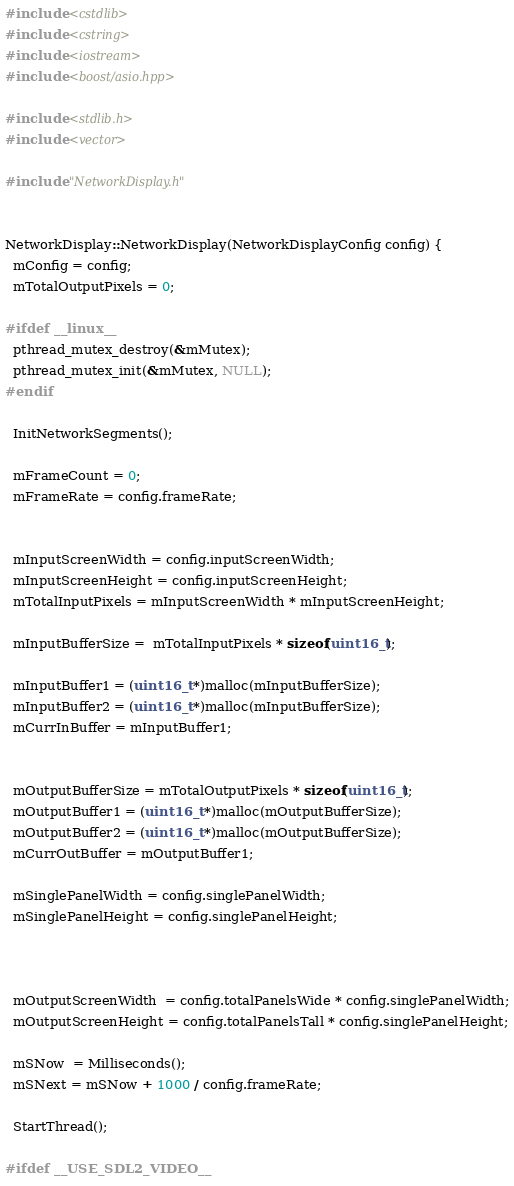<code> <loc_0><loc_0><loc_500><loc_500><_C++_>#include <cstdlib>
#include <cstring>
#include <iostream>
#include <boost/asio.hpp>

#include <stdlib.h>
#include <vector>

#include "NetworkDisplay.h"


NetworkDisplay::NetworkDisplay(NetworkDisplayConfig config) {
  mConfig = config;
  mTotalOutputPixels = 0;

#ifdef __linux__
  pthread_mutex_destroy(&mMutex);
  pthread_mutex_init(&mMutex, NULL);
#endif

  InitNetworkSegments();

  mFrameCount = 0;
  mFrameRate = config.frameRate;


  mInputScreenWidth = config.inputScreenWidth;
  mInputScreenHeight = config.inputScreenHeight;
  mTotalInputPixels = mInputScreenWidth * mInputScreenHeight;

  mInputBufferSize =  mTotalInputPixels * sizeof(uint16_t);

  mInputBuffer1 = (uint16_t *)malloc(mInputBufferSize);
  mInputBuffer2 = (uint16_t *)malloc(mInputBufferSize);
  mCurrInBuffer = mInputBuffer1;


  mOutputBufferSize = mTotalOutputPixels * sizeof(uint16_t);
  mOutputBuffer1 = (uint16_t *)malloc(mOutputBufferSize);
  mOutputBuffer2 = (uint16_t *)malloc(mOutputBufferSize);
  mCurrOutBuffer = mOutputBuffer1;

  mSinglePanelWidth = config.singlePanelWidth;
  mSinglePanelHeight = config.singlePanelHeight;



  mOutputScreenWidth  = config.totalPanelsWide * config.singlePanelWidth;
  mOutputScreenHeight = config.totalPanelsTall * config.singlePanelHeight;

  mSNow  = Milliseconds();
  mSNext = mSNow + 1000 / config.frameRate;

  StartThread();

#ifdef __USE_SDL2_VIDEO__</code> 